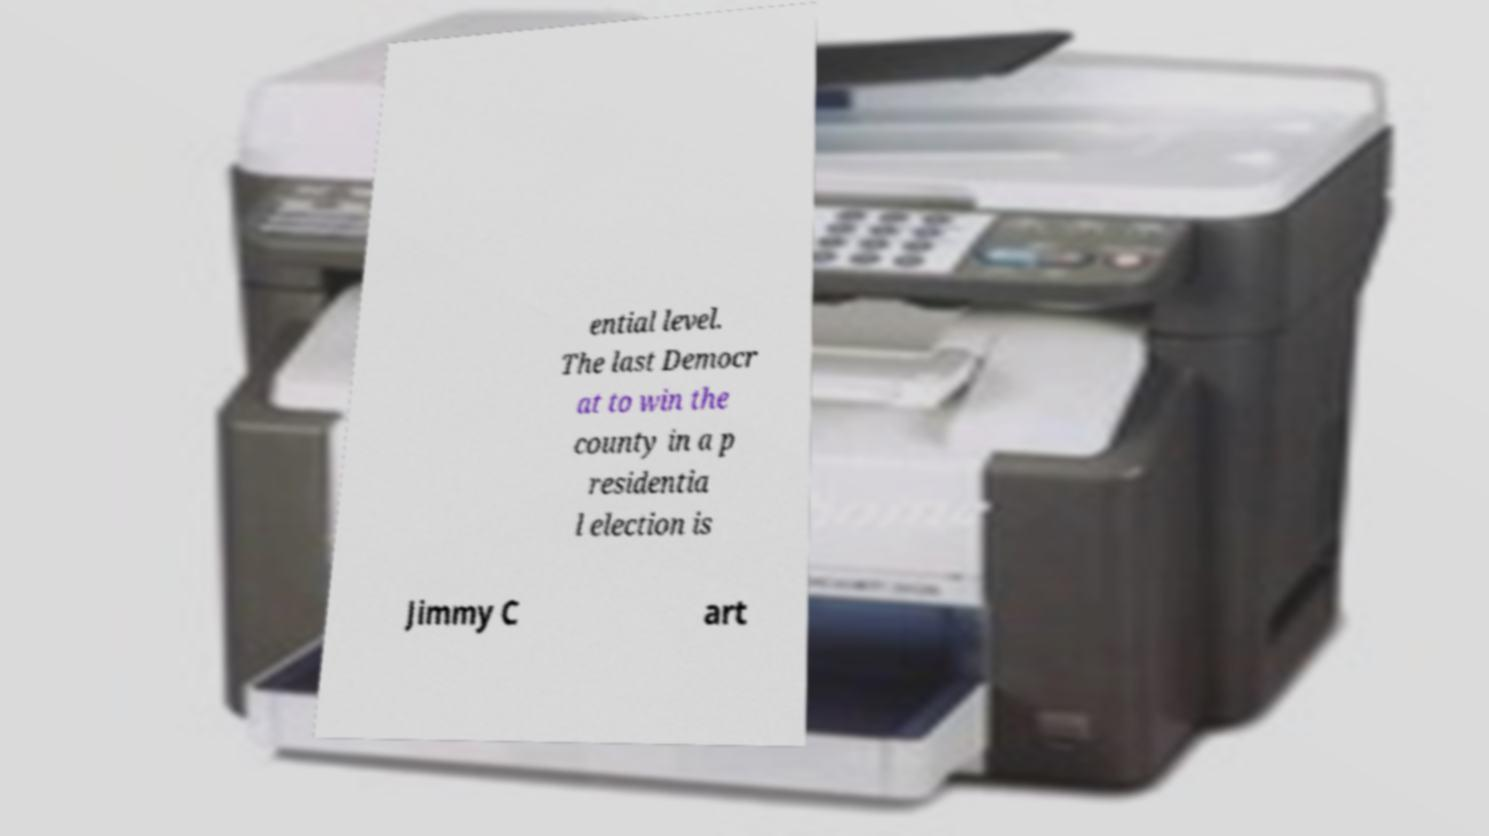Can you accurately transcribe the text from the provided image for me? ential level. The last Democr at to win the county in a p residentia l election is Jimmy C art 